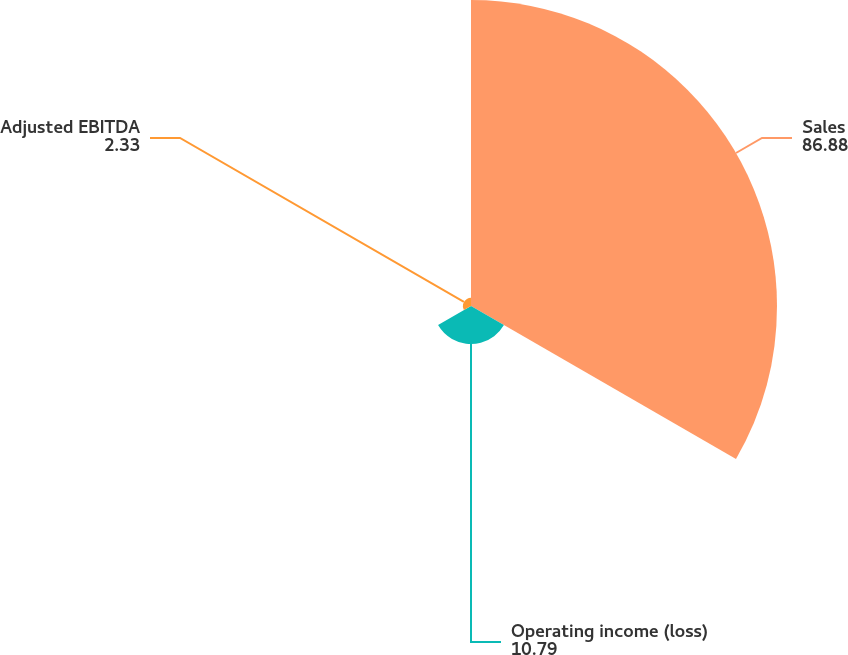<chart> <loc_0><loc_0><loc_500><loc_500><pie_chart><fcel>Sales<fcel>Operating income (loss)<fcel>Adjusted EBITDA<nl><fcel>86.88%<fcel>10.79%<fcel>2.33%<nl></chart> 